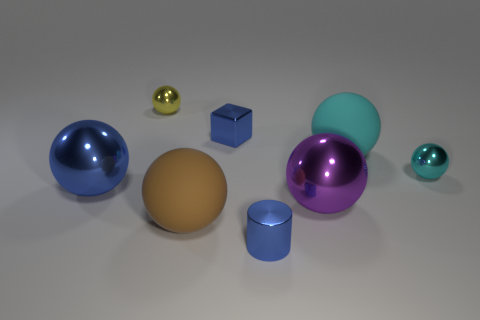How many other objects are the same color as the tiny metallic cube? There are two objects that share the same blue hue as the tiny metallic cube: one is a larger shiny sphere and the other is a cylindrical shape with a similar reflective surface. 